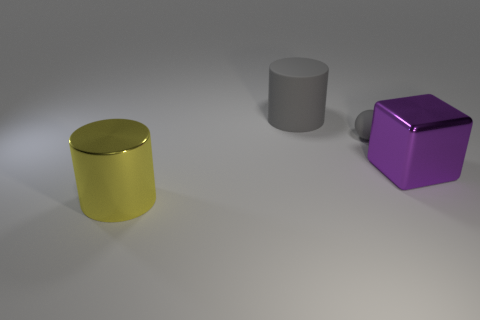Add 3 big gray cylinders. How many objects exist? 7 Subtract all gray matte balls. Subtract all gray matte cylinders. How many objects are left? 2 Add 1 small rubber balls. How many small rubber balls are left? 2 Add 3 big shiny objects. How many big shiny objects exist? 5 Subtract 0 gray blocks. How many objects are left? 4 